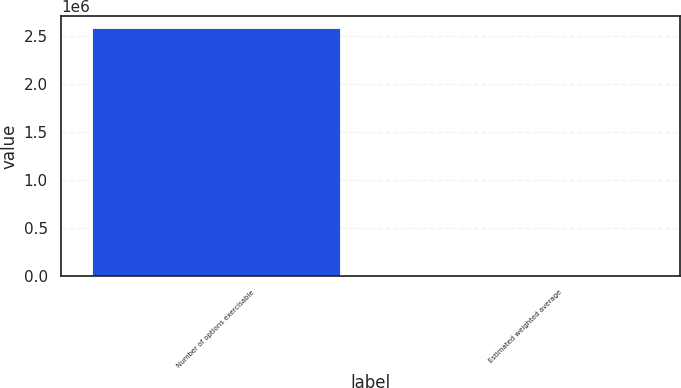Convert chart. <chart><loc_0><loc_0><loc_500><loc_500><bar_chart><fcel>Number of options exercisable<fcel>Estimated weighted average<nl><fcel>2.58142e+06<fcel>12.8<nl></chart> 